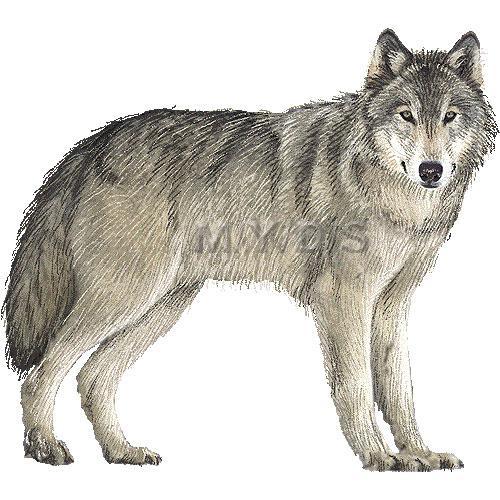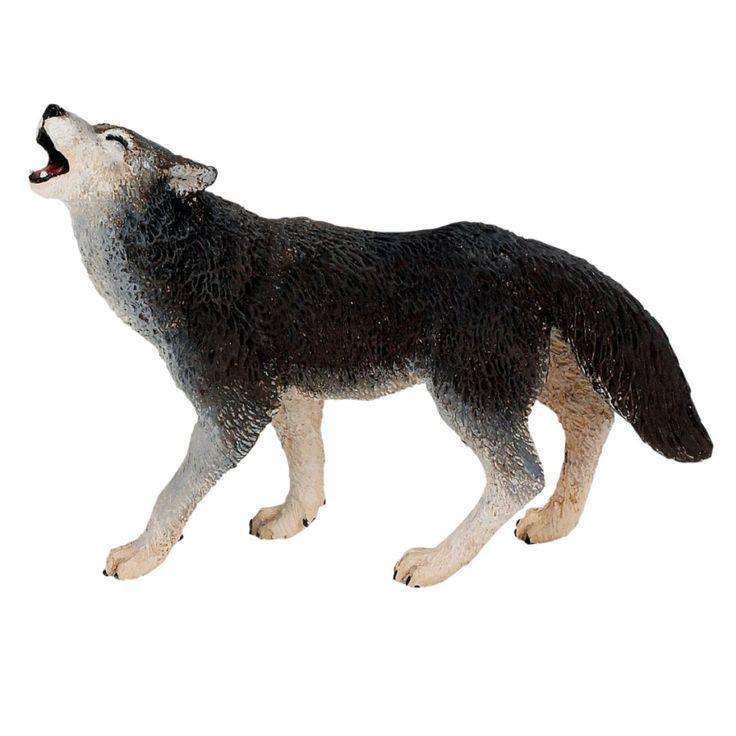The first image is the image on the left, the second image is the image on the right. For the images shown, is this caption "One image shows a howling wolf with raised head." true? Answer yes or no. Yes. 